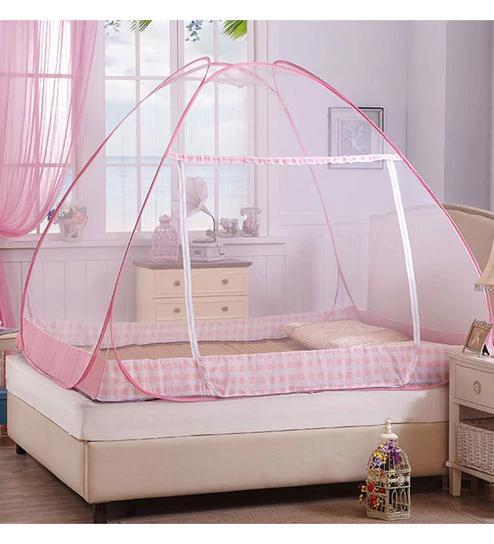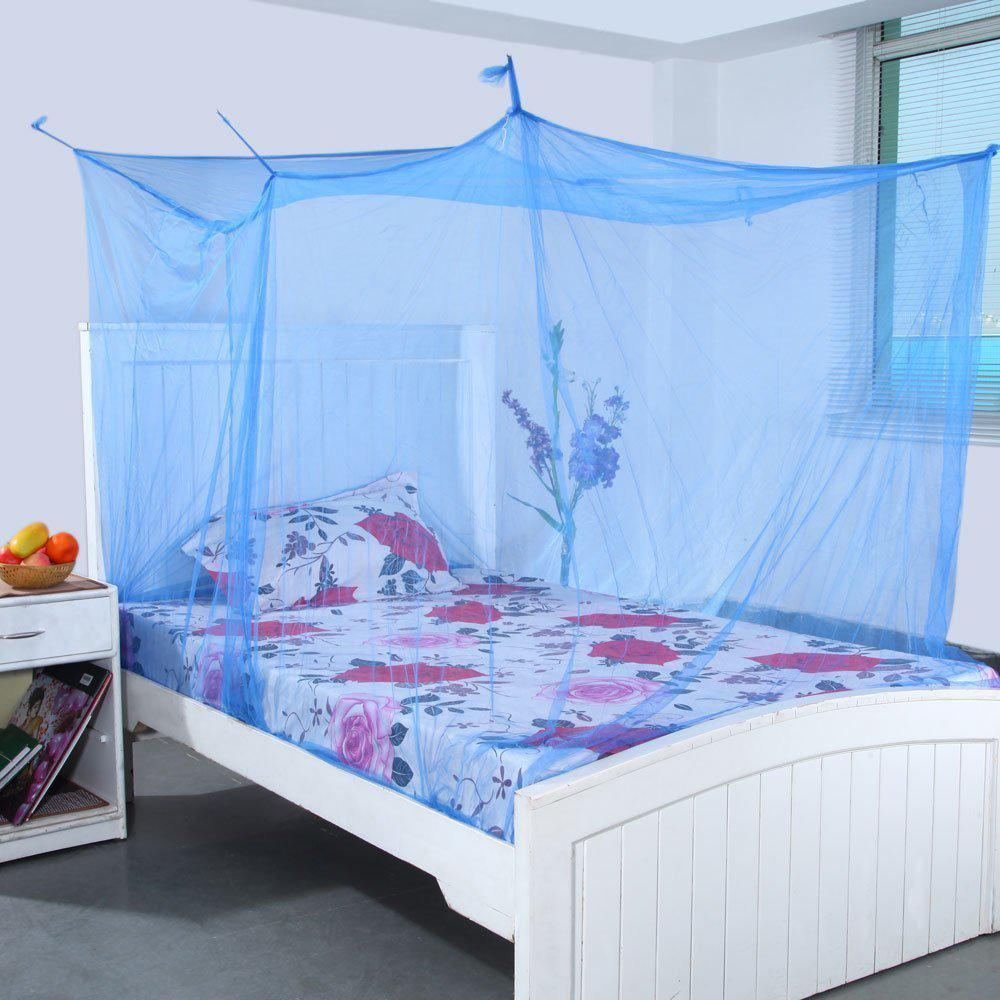The first image is the image on the left, the second image is the image on the right. Examine the images to the left and right. Is the description "Both beds have headboards." accurate? Answer yes or no. Yes. 